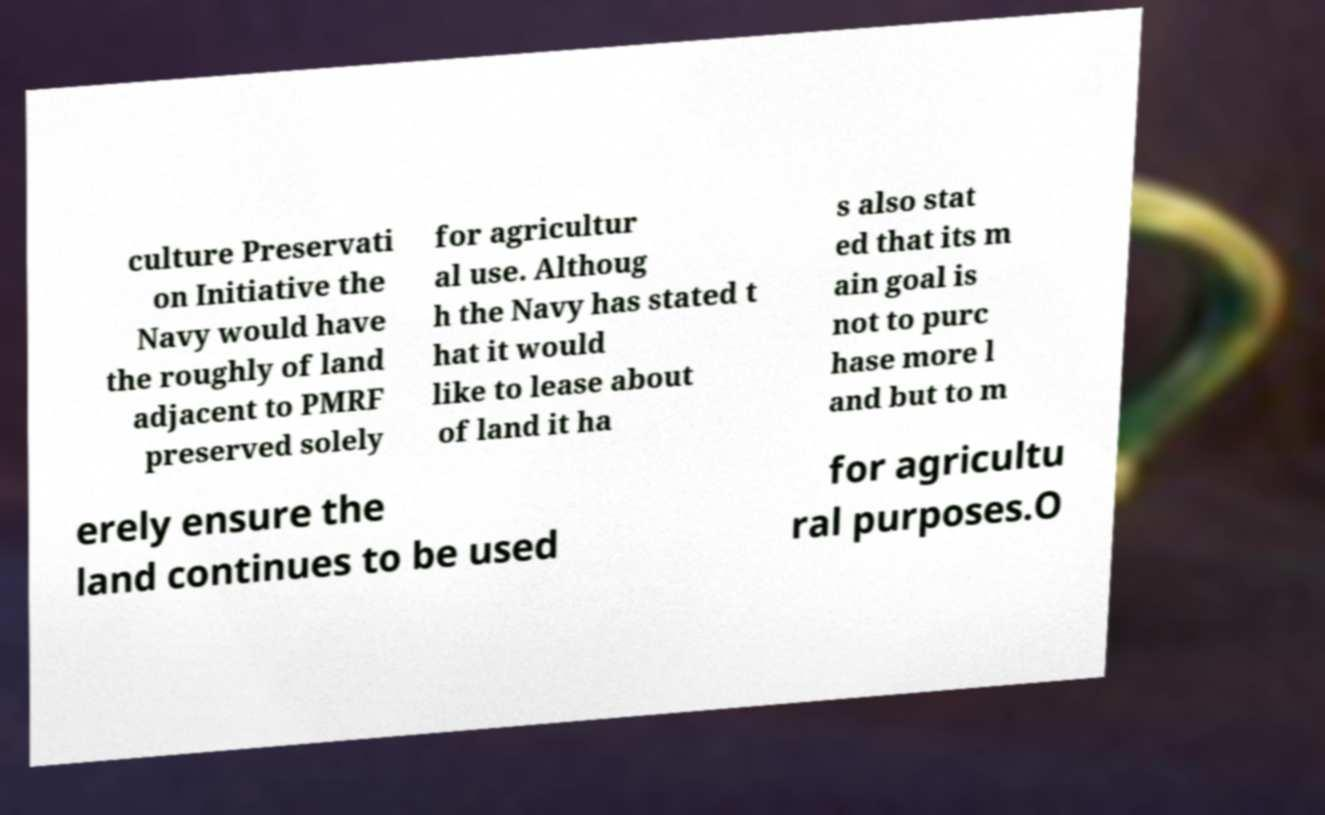Can you read and provide the text displayed in the image?This photo seems to have some interesting text. Can you extract and type it out for me? culture Preservati on Initiative the Navy would have the roughly of land adjacent to PMRF preserved solely for agricultur al use. Althoug h the Navy has stated t hat it would like to lease about of land it ha s also stat ed that its m ain goal is not to purc hase more l and but to m erely ensure the land continues to be used for agricultu ral purposes.O 